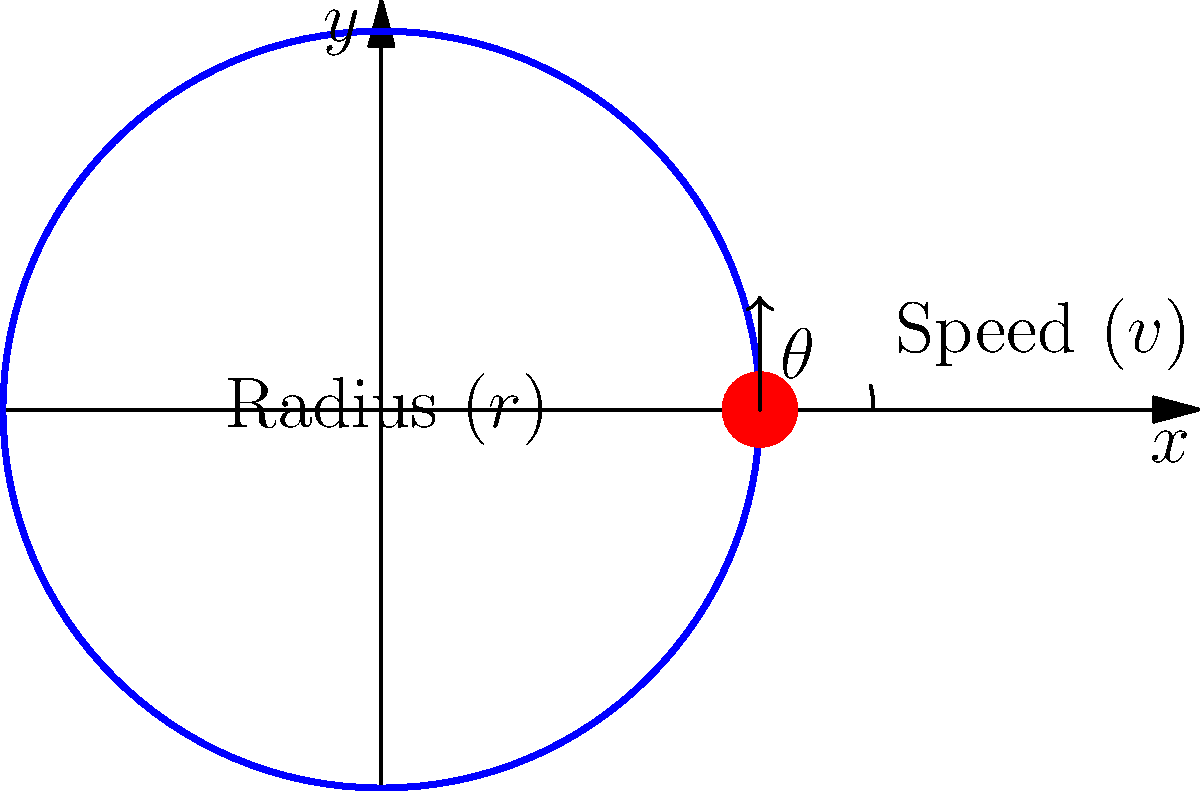Your brother wants to explain the physics of banked turns in NASCAR to your students. He tells you that the banking angle $\theta$ of a circular race track can be determined using the formula:

$$\tan \theta = \frac{v^2}{rg}$$

where $v$ is the speed of the car, $r$ is the radius of the turn, and $g$ is the acceleration due to gravity (approximately 9.8 m/s²).

If a car is traveling at 180 km/h (50 m/s) around a turn with a radius of 100 meters, what is the ideal banking angle of the track in degrees? Round your answer to the nearest whole number. Let's approach this step-by-step:

1) We're given:
   - Speed ($v$) = 180 km/h = 50 m/s
   - Radius ($r$) = 100 m
   - Acceleration due to gravity ($g$) = 9.8 m/s²

2) We need to use the formula: $\tan \theta = \frac{v^2}{rg}$

3) Let's substitute our values:

   $\tan \theta = \frac{(50 \text{ m/s})^2}{(100 \text{ m})(9.8 \text{ m/s}^2)}$

4) Simplify:
   $\tan \theta = \frac{2500}{980} \approx 2.5510$

5) Now we need to find $\theta$. We can do this by taking the inverse tangent (arctan or $\tan^{-1}$) of both sides:

   $\theta = \tan^{-1}(2.5510)$

6) Using a calculator or computer:
   $\theta \approx 68.63°$

7) Rounding to the nearest whole number:
   $\theta \approx 69°$

This means that for a car traveling at 180 km/h around a turn with a radius of 100 meters, the ideal banking angle would be approximately 69°.
Answer: 69° 